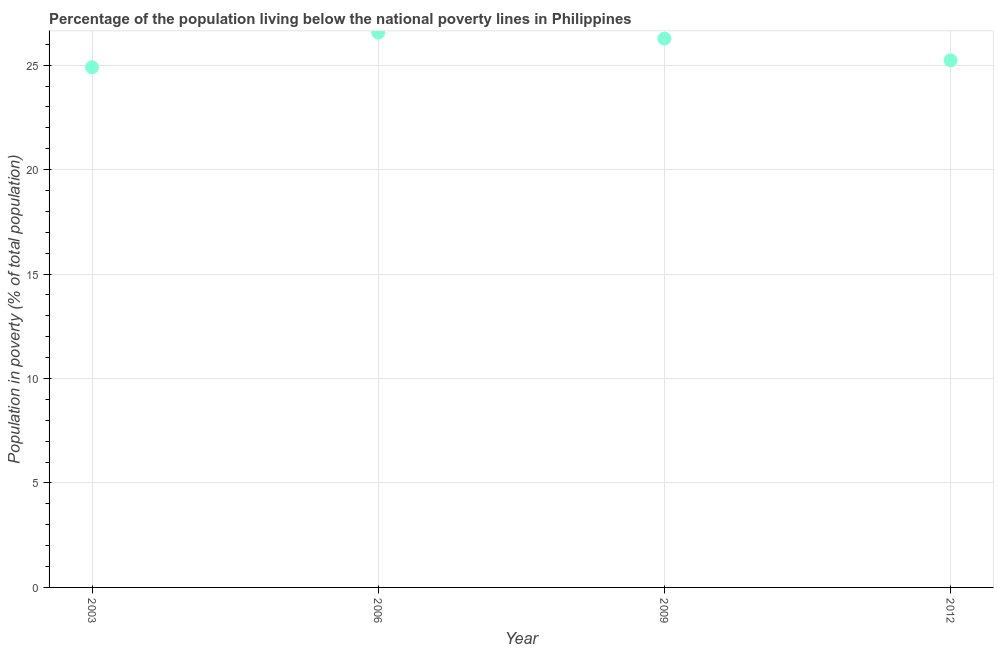What is the percentage of population living below poverty line in 2003?
Your answer should be very brief. 24.9. Across all years, what is the maximum percentage of population living below poverty line?
Make the answer very short. 26.56. Across all years, what is the minimum percentage of population living below poverty line?
Your response must be concise. 24.9. In which year was the percentage of population living below poverty line maximum?
Your response must be concise. 2006. In which year was the percentage of population living below poverty line minimum?
Your response must be concise. 2003. What is the sum of the percentage of population living below poverty line?
Provide a short and direct response. 102.97. What is the difference between the percentage of population living below poverty line in 2003 and 2012?
Ensure brevity in your answer.  -0.33. What is the average percentage of population living below poverty line per year?
Your answer should be compact. 25.74. What is the median percentage of population living below poverty line?
Offer a very short reply. 25.75. In how many years, is the percentage of population living below poverty line greater than 25 %?
Provide a succinct answer. 3. What is the ratio of the percentage of population living below poverty line in 2006 to that in 2012?
Your response must be concise. 1.05. Is the percentage of population living below poverty line in 2006 less than that in 2012?
Offer a very short reply. No. Is the difference between the percentage of population living below poverty line in 2003 and 2012 greater than the difference between any two years?
Your response must be concise. No. What is the difference between the highest and the second highest percentage of population living below poverty line?
Offer a terse response. 0.29. Is the sum of the percentage of population living below poverty line in 2009 and 2012 greater than the maximum percentage of population living below poverty line across all years?
Offer a terse response. Yes. What is the difference between the highest and the lowest percentage of population living below poverty line?
Make the answer very short. 1.66. How many years are there in the graph?
Provide a succinct answer. 4. What is the difference between two consecutive major ticks on the Y-axis?
Give a very brief answer. 5. Are the values on the major ticks of Y-axis written in scientific E-notation?
Give a very brief answer. No. Does the graph contain any zero values?
Give a very brief answer. No. Does the graph contain grids?
Provide a succinct answer. Yes. What is the title of the graph?
Keep it short and to the point. Percentage of the population living below the national poverty lines in Philippines. What is the label or title of the X-axis?
Provide a succinct answer. Year. What is the label or title of the Y-axis?
Provide a short and direct response. Population in poverty (% of total population). What is the Population in poverty (% of total population) in 2003?
Your answer should be compact. 24.9. What is the Population in poverty (% of total population) in 2006?
Your response must be concise. 26.56. What is the Population in poverty (% of total population) in 2009?
Your answer should be compact. 26.27. What is the Population in poverty (% of total population) in 2012?
Offer a terse response. 25.23. What is the difference between the Population in poverty (% of total population) in 2003 and 2006?
Offer a terse response. -1.66. What is the difference between the Population in poverty (% of total population) in 2003 and 2009?
Your response must be concise. -1.37. What is the difference between the Population in poverty (% of total population) in 2003 and 2012?
Make the answer very short. -0.33. What is the difference between the Population in poverty (% of total population) in 2006 and 2009?
Offer a terse response. 0.29. What is the difference between the Population in poverty (% of total population) in 2006 and 2012?
Your answer should be very brief. 1.33. What is the difference between the Population in poverty (% of total population) in 2009 and 2012?
Your answer should be compact. 1.04. What is the ratio of the Population in poverty (% of total population) in 2003 to that in 2006?
Your response must be concise. 0.94. What is the ratio of the Population in poverty (% of total population) in 2003 to that in 2009?
Provide a succinct answer. 0.95. What is the ratio of the Population in poverty (% of total population) in 2003 to that in 2012?
Your answer should be compact. 0.99. What is the ratio of the Population in poverty (% of total population) in 2006 to that in 2009?
Offer a very short reply. 1.01. What is the ratio of the Population in poverty (% of total population) in 2006 to that in 2012?
Keep it short and to the point. 1.05. What is the ratio of the Population in poverty (% of total population) in 2009 to that in 2012?
Your answer should be very brief. 1.04. 